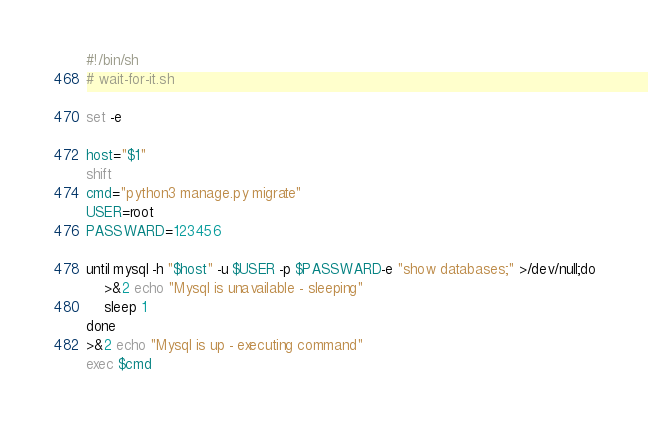Convert code to text. <code><loc_0><loc_0><loc_500><loc_500><_Bash_>#!/bin/sh
# wait-for-it.sh

set -e

host="$1"
shift
cmd="python3 manage.py migrate"
USER=root
PASSWARD=123456

until mysql -h "$host" -u $USER -p $PASSWARD-e "show databases;" >/dev/null;do
    >&2 echo "Mysql is unavailable - sleeping"
    sleep 1
done
>&2 echo "Mysql is up - executing command"
exec $cmd
</code> 